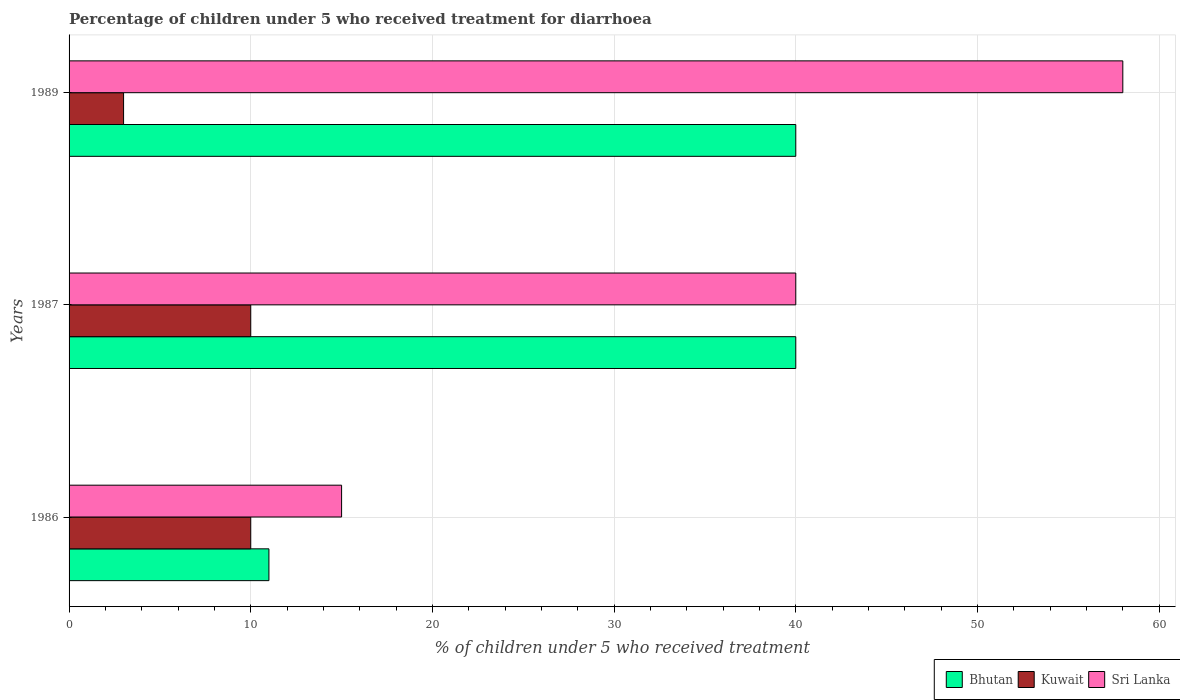How many groups of bars are there?
Offer a terse response. 3. Are the number of bars on each tick of the Y-axis equal?
Make the answer very short. Yes. How many bars are there on the 3rd tick from the top?
Offer a very short reply. 3. How many bars are there on the 1st tick from the bottom?
Provide a short and direct response. 3. What is the percentage of children who received treatment for diarrhoea  in Bhutan in 1986?
Make the answer very short. 11. Across all years, what is the maximum percentage of children who received treatment for diarrhoea  in Sri Lanka?
Provide a succinct answer. 58. In which year was the percentage of children who received treatment for diarrhoea  in Sri Lanka maximum?
Your response must be concise. 1989. In which year was the percentage of children who received treatment for diarrhoea  in Kuwait minimum?
Offer a terse response. 1989. What is the total percentage of children who received treatment for diarrhoea  in Sri Lanka in the graph?
Ensure brevity in your answer.  113. What is the average percentage of children who received treatment for diarrhoea  in Bhutan per year?
Offer a very short reply. 30.33. What is the ratio of the percentage of children who received treatment for diarrhoea  in Bhutan in 1987 to that in 1989?
Your response must be concise. 1. Is the percentage of children who received treatment for diarrhoea  in Bhutan in 1986 less than that in 1987?
Keep it short and to the point. Yes. In how many years, is the percentage of children who received treatment for diarrhoea  in Kuwait greater than the average percentage of children who received treatment for diarrhoea  in Kuwait taken over all years?
Ensure brevity in your answer.  2. What does the 3rd bar from the top in 1989 represents?
Ensure brevity in your answer.  Bhutan. What does the 2nd bar from the bottom in 1989 represents?
Keep it short and to the point. Kuwait. Are all the bars in the graph horizontal?
Your response must be concise. Yes. How many years are there in the graph?
Make the answer very short. 3. What is the difference between two consecutive major ticks on the X-axis?
Provide a short and direct response. 10. Where does the legend appear in the graph?
Ensure brevity in your answer.  Bottom right. What is the title of the graph?
Offer a very short reply. Percentage of children under 5 who received treatment for diarrhoea. Does "Iraq" appear as one of the legend labels in the graph?
Offer a very short reply. No. What is the label or title of the X-axis?
Offer a very short reply. % of children under 5 who received treatment. What is the % of children under 5 who received treatment in Kuwait in 1989?
Ensure brevity in your answer.  3. Across all years, what is the maximum % of children under 5 who received treatment of Bhutan?
Your response must be concise. 40. Across all years, what is the maximum % of children under 5 who received treatment of Kuwait?
Ensure brevity in your answer.  10. Across all years, what is the minimum % of children under 5 who received treatment in Bhutan?
Offer a very short reply. 11. What is the total % of children under 5 who received treatment of Bhutan in the graph?
Offer a very short reply. 91. What is the total % of children under 5 who received treatment of Sri Lanka in the graph?
Give a very brief answer. 113. What is the difference between the % of children under 5 who received treatment in Bhutan in 1986 and that in 1987?
Your response must be concise. -29. What is the difference between the % of children under 5 who received treatment in Sri Lanka in 1986 and that in 1987?
Your response must be concise. -25. What is the difference between the % of children under 5 who received treatment of Sri Lanka in 1986 and that in 1989?
Keep it short and to the point. -43. What is the difference between the % of children under 5 who received treatment in Bhutan in 1987 and that in 1989?
Provide a succinct answer. 0. What is the difference between the % of children under 5 who received treatment in Bhutan in 1986 and the % of children under 5 who received treatment in Kuwait in 1987?
Your answer should be compact. 1. What is the difference between the % of children under 5 who received treatment of Bhutan in 1986 and the % of children under 5 who received treatment of Kuwait in 1989?
Your answer should be compact. 8. What is the difference between the % of children under 5 who received treatment of Bhutan in 1986 and the % of children under 5 who received treatment of Sri Lanka in 1989?
Give a very brief answer. -47. What is the difference between the % of children under 5 who received treatment of Kuwait in 1986 and the % of children under 5 who received treatment of Sri Lanka in 1989?
Offer a terse response. -48. What is the difference between the % of children under 5 who received treatment in Kuwait in 1987 and the % of children under 5 who received treatment in Sri Lanka in 1989?
Your response must be concise. -48. What is the average % of children under 5 who received treatment of Bhutan per year?
Offer a very short reply. 30.33. What is the average % of children under 5 who received treatment of Kuwait per year?
Make the answer very short. 7.67. What is the average % of children under 5 who received treatment in Sri Lanka per year?
Provide a succinct answer. 37.67. In the year 1986, what is the difference between the % of children under 5 who received treatment in Bhutan and % of children under 5 who received treatment in Kuwait?
Your answer should be very brief. 1. In the year 1986, what is the difference between the % of children under 5 who received treatment in Bhutan and % of children under 5 who received treatment in Sri Lanka?
Your answer should be very brief. -4. In the year 1986, what is the difference between the % of children under 5 who received treatment of Kuwait and % of children under 5 who received treatment of Sri Lanka?
Offer a very short reply. -5. In the year 1987, what is the difference between the % of children under 5 who received treatment of Bhutan and % of children under 5 who received treatment of Kuwait?
Ensure brevity in your answer.  30. In the year 1987, what is the difference between the % of children under 5 who received treatment of Kuwait and % of children under 5 who received treatment of Sri Lanka?
Your answer should be very brief. -30. In the year 1989, what is the difference between the % of children under 5 who received treatment of Bhutan and % of children under 5 who received treatment of Sri Lanka?
Offer a very short reply. -18. In the year 1989, what is the difference between the % of children under 5 who received treatment in Kuwait and % of children under 5 who received treatment in Sri Lanka?
Provide a short and direct response. -55. What is the ratio of the % of children under 5 who received treatment of Bhutan in 1986 to that in 1987?
Make the answer very short. 0.28. What is the ratio of the % of children under 5 who received treatment of Bhutan in 1986 to that in 1989?
Ensure brevity in your answer.  0.28. What is the ratio of the % of children under 5 who received treatment in Kuwait in 1986 to that in 1989?
Offer a terse response. 3.33. What is the ratio of the % of children under 5 who received treatment in Sri Lanka in 1986 to that in 1989?
Your answer should be very brief. 0.26. What is the ratio of the % of children under 5 who received treatment in Kuwait in 1987 to that in 1989?
Offer a terse response. 3.33. What is the ratio of the % of children under 5 who received treatment of Sri Lanka in 1987 to that in 1989?
Keep it short and to the point. 0.69. What is the difference between the highest and the second highest % of children under 5 who received treatment of Bhutan?
Offer a very short reply. 0. What is the difference between the highest and the second highest % of children under 5 who received treatment of Kuwait?
Make the answer very short. 0. What is the difference between the highest and the second highest % of children under 5 who received treatment of Sri Lanka?
Provide a succinct answer. 18. 